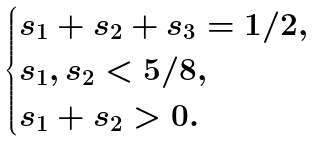<formula> <loc_0><loc_0><loc_500><loc_500>\begin{cases} s _ { 1 } + s _ { 2 } + s _ { 3 } = 1 / 2 , \\ s _ { 1 } , s _ { 2 } < 5 / 8 , \\ s _ { 1 } + s _ { 2 } > 0 . \end{cases}</formula> 